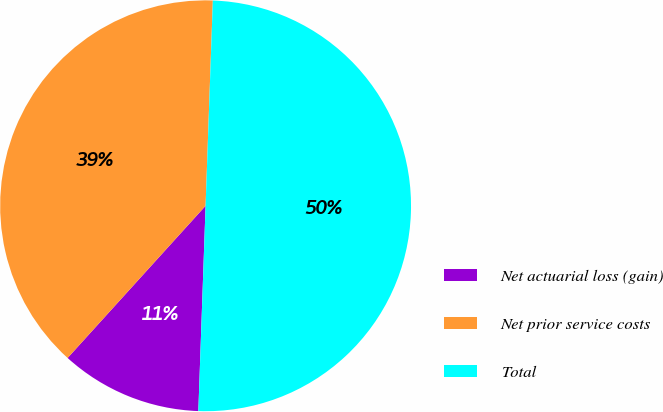Convert chart. <chart><loc_0><loc_0><loc_500><loc_500><pie_chart><fcel>Net actuarial loss (gain)<fcel>Net prior service costs<fcel>Total<nl><fcel>11.16%<fcel>38.84%<fcel>50.0%<nl></chart> 